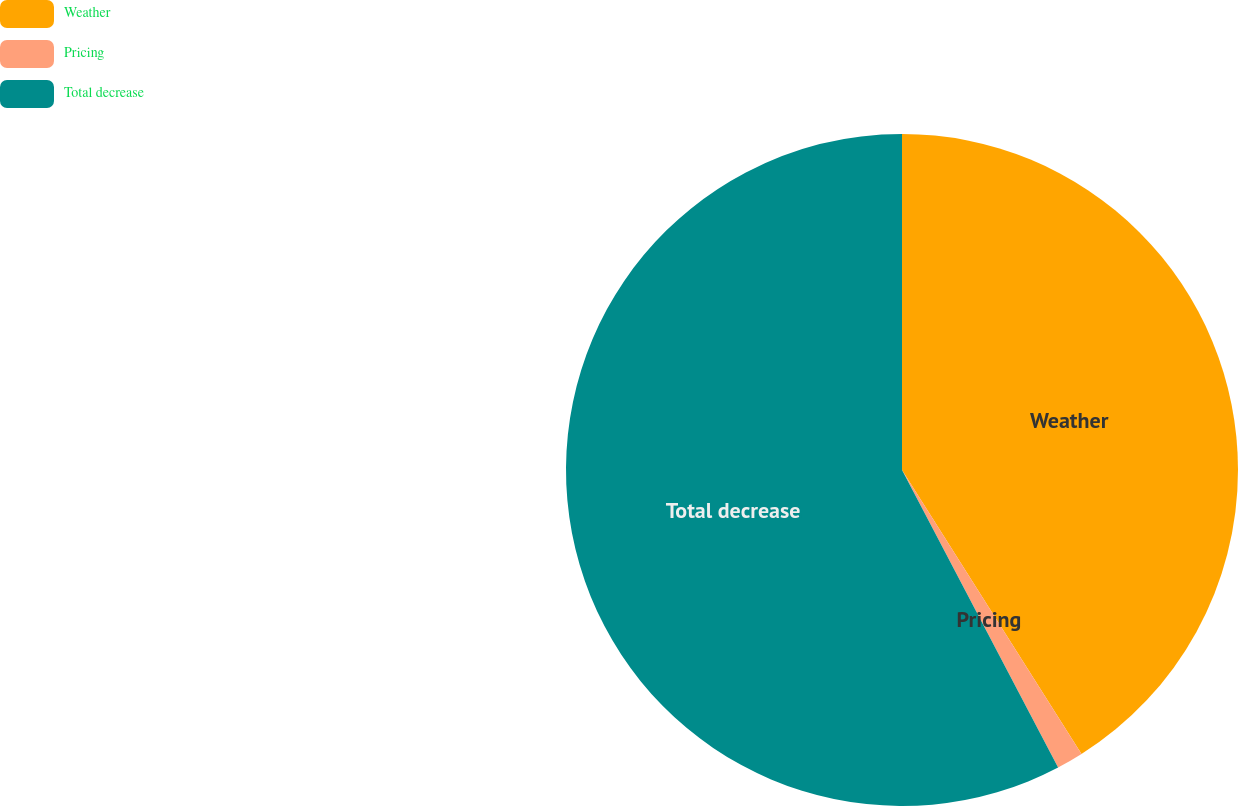<chart> <loc_0><loc_0><loc_500><loc_500><pie_chart><fcel>Weather<fcel>Pricing<fcel>Total decrease<nl><fcel>41.03%<fcel>1.28%<fcel>57.69%<nl></chart> 